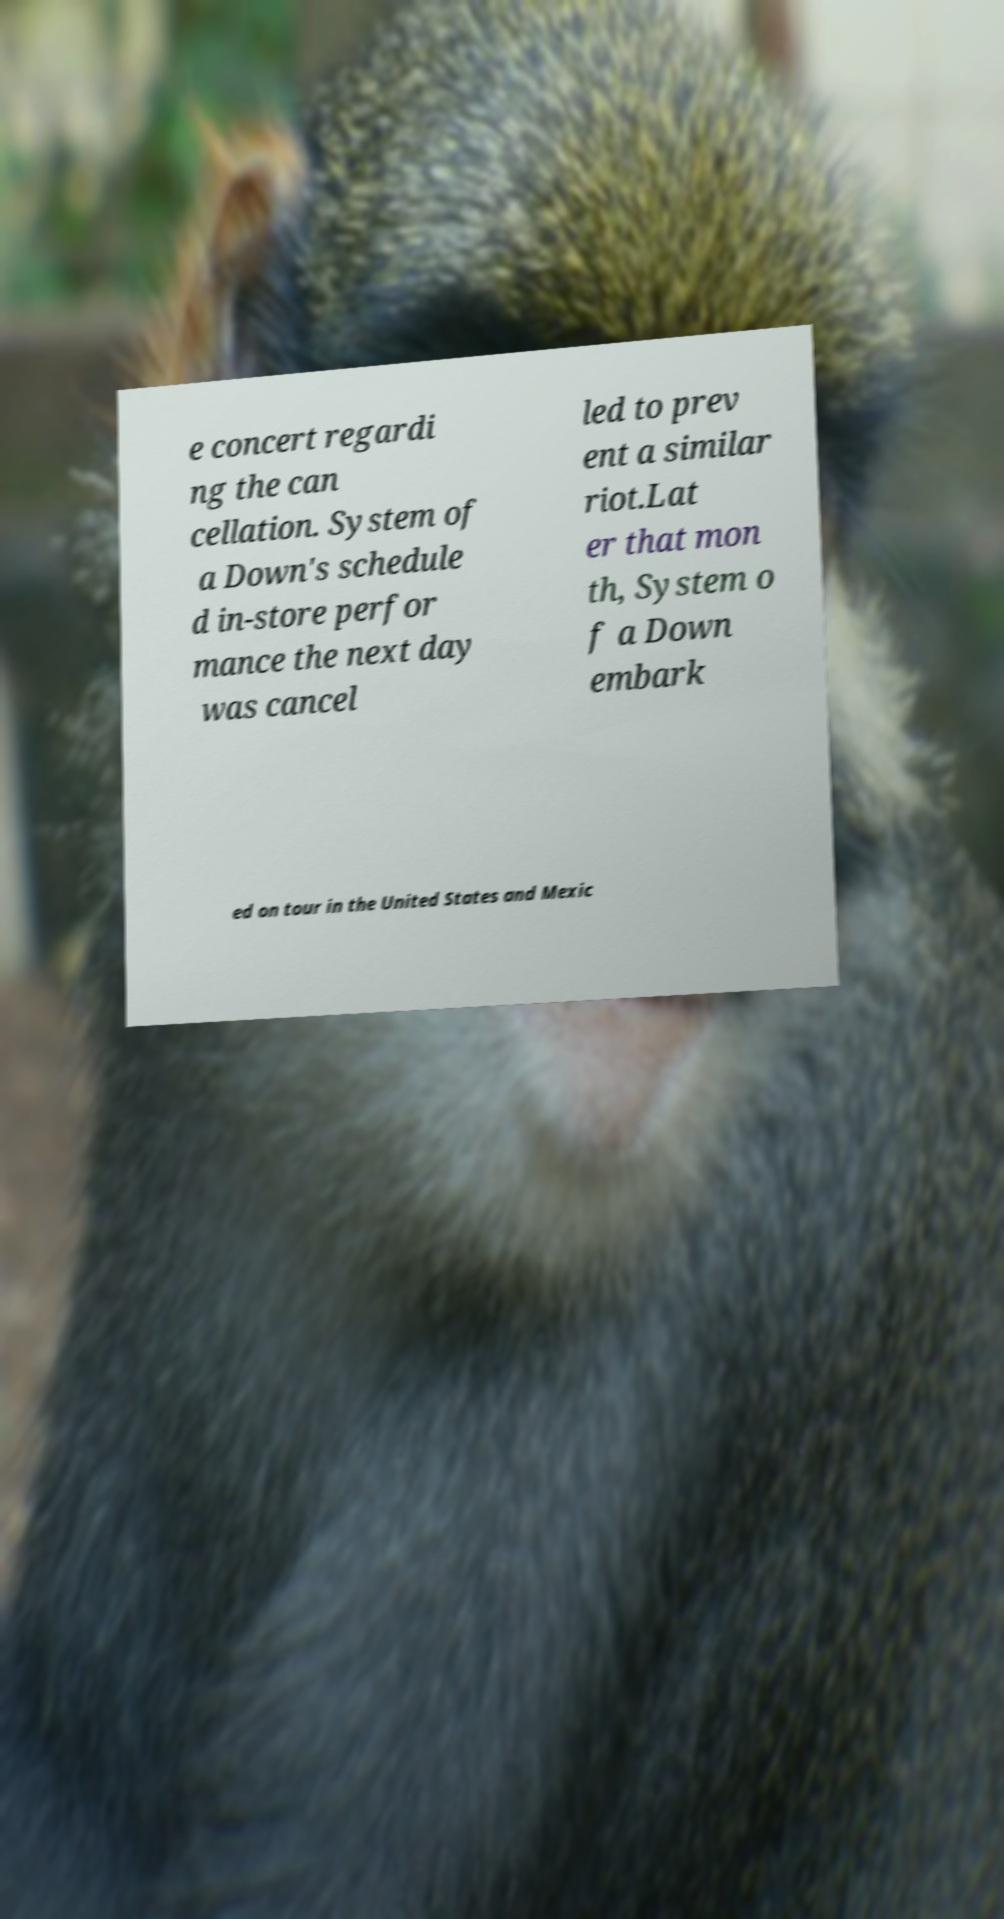There's text embedded in this image that I need extracted. Can you transcribe it verbatim? e concert regardi ng the can cellation. System of a Down's schedule d in-store perfor mance the next day was cancel led to prev ent a similar riot.Lat er that mon th, System o f a Down embark ed on tour in the United States and Mexic 